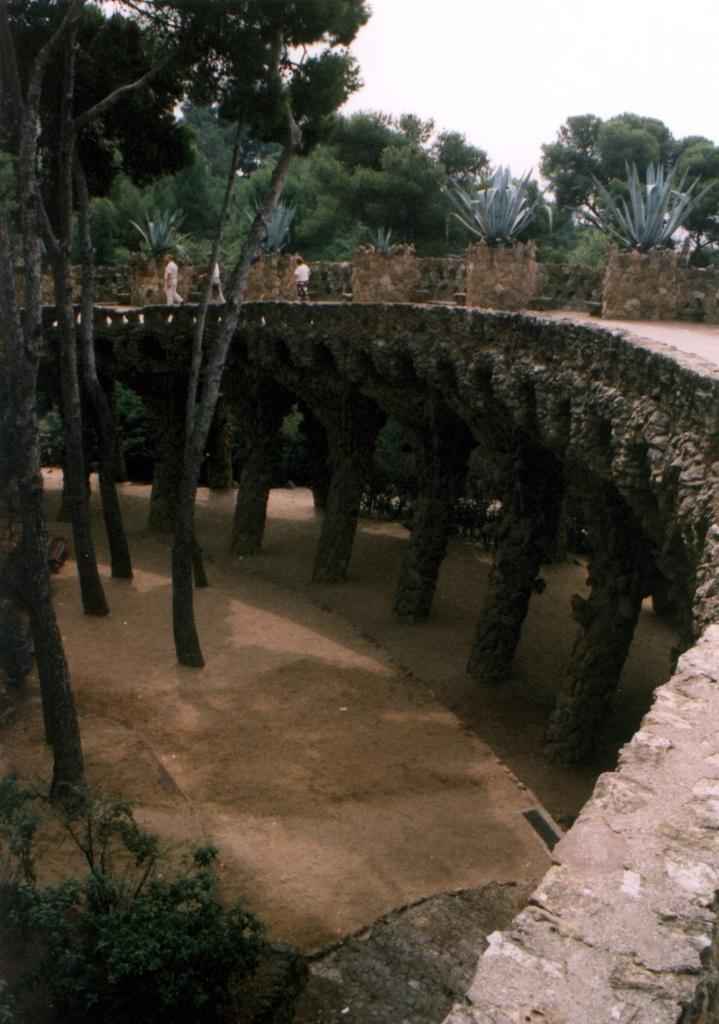What structure is located on the right side of the image? There is a bridge in the image, and it is located on the right side. Where is the person in the image positioned? The person is near the bridge in the image. What type of vegetation is around the bridge? There are trees around the bridge in the image. What is visible at the top of the image? The sky is visible at the top of the image. What can be seen in the bottom left of the image? There is a plant in the bottom left of the image. How does the person use the brush to clean the drain in the image? There is no brush or drain present in the image; it features a bridge, a person, trees, and a plant. 